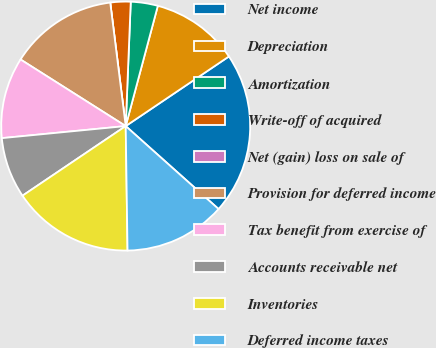Convert chart. <chart><loc_0><loc_0><loc_500><loc_500><pie_chart><fcel>Net income<fcel>Depreciation<fcel>Amortization<fcel>Write-off of acquired<fcel>Net (gain) loss on sale of<fcel>Provision for deferred income<fcel>Tax benefit from exercise of<fcel>Accounts receivable net<fcel>Inventories<fcel>Deferred income taxes<nl><fcel>21.05%<fcel>11.4%<fcel>3.51%<fcel>2.63%<fcel>0.0%<fcel>14.03%<fcel>10.53%<fcel>7.9%<fcel>15.79%<fcel>13.16%<nl></chart> 